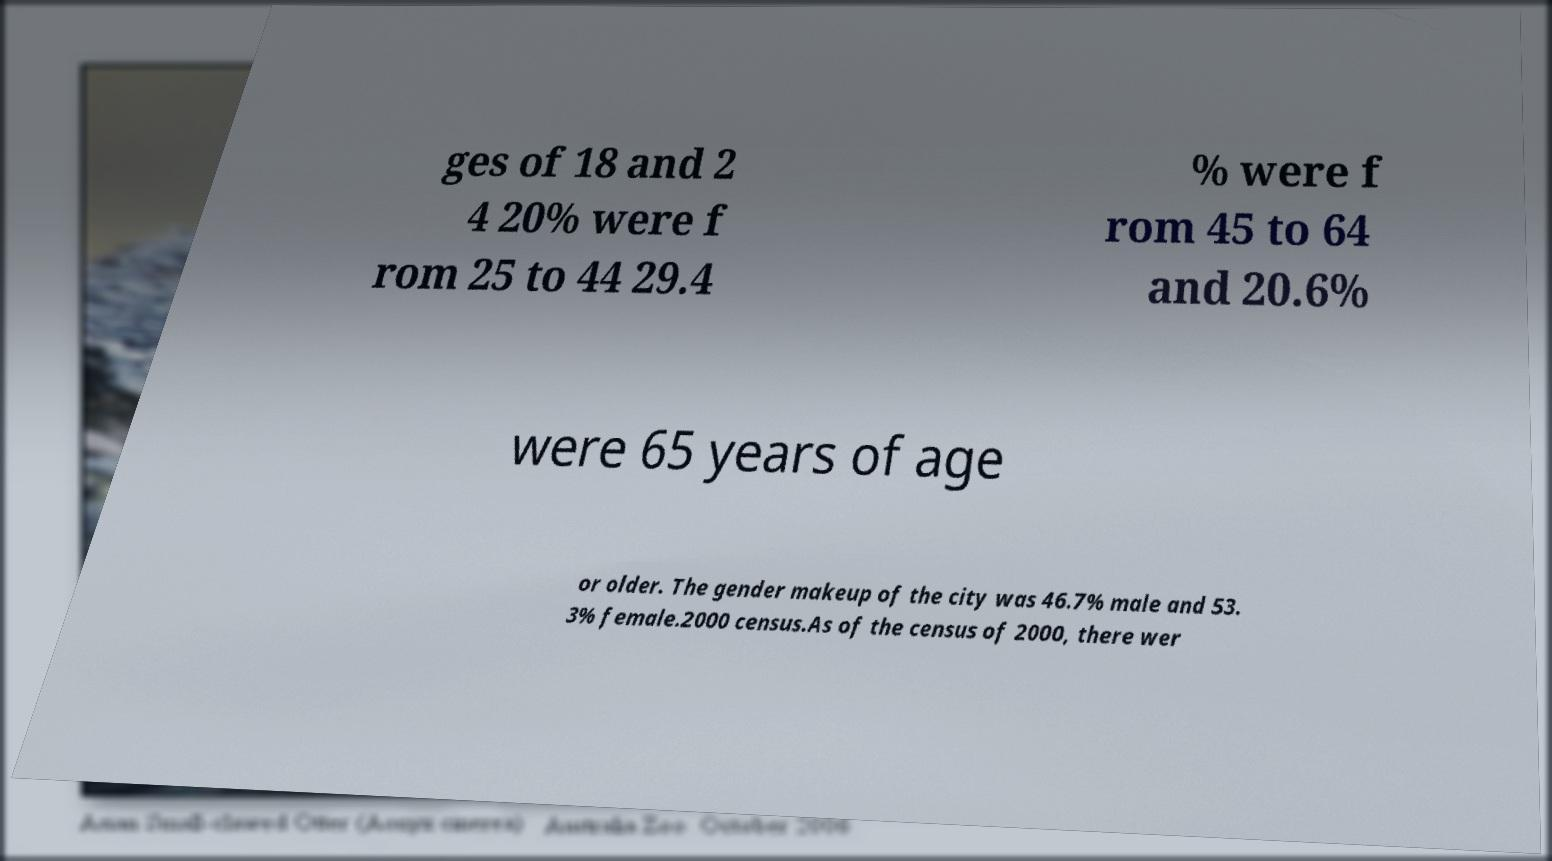Can you accurately transcribe the text from the provided image for me? ges of 18 and 2 4 20% were f rom 25 to 44 29.4 % were f rom 45 to 64 and 20.6% were 65 years of age or older. The gender makeup of the city was 46.7% male and 53. 3% female.2000 census.As of the census of 2000, there wer 